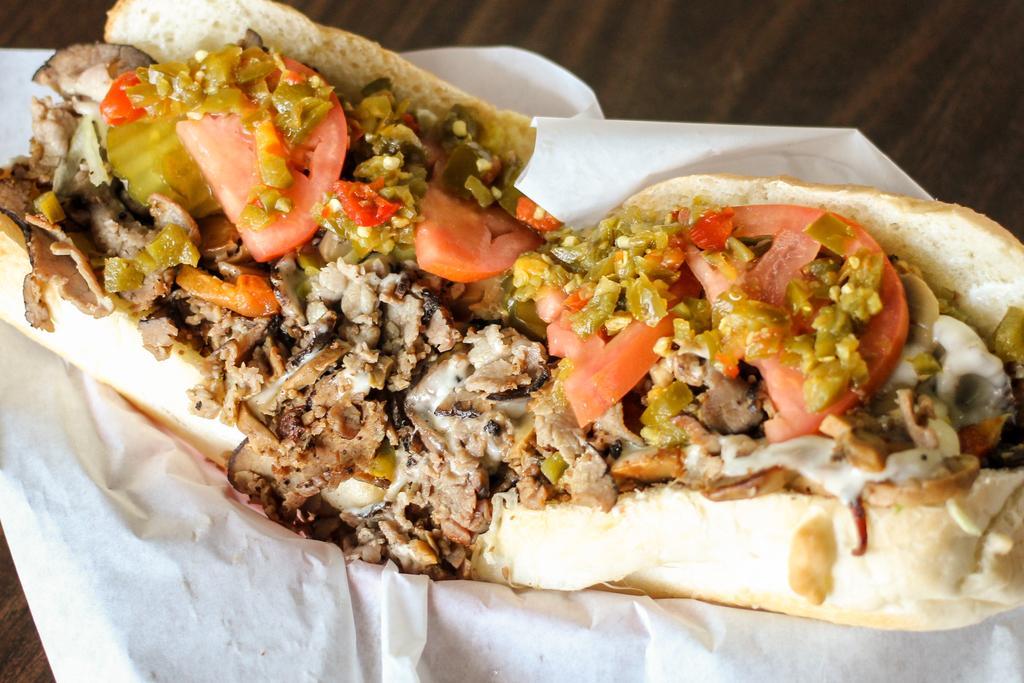How would you summarize this image in a sentence or two? In this image, we can see a table, on that table, we can see tissue, on the tissue, we can see some food item. 